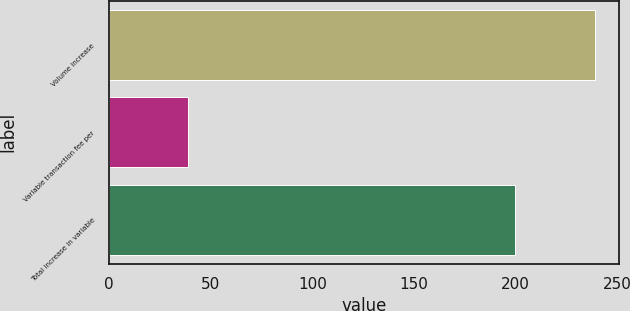<chart> <loc_0><loc_0><loc_500><loc_500><bar_chart><fcel>Volume increase<fcel>Variable transaction fee per<fcel>Total increase in variable<nl><fcel>239<fcel>39<fcel>200<nl></chart> 